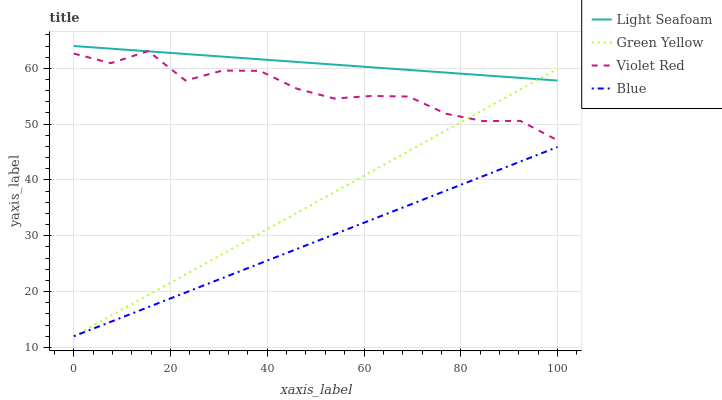Does Blue have the minimum area under the curve?
Answer yes or no. Yes. Does Light Seafoam have the maximum area under the curve?
Answer yes or no. Yes. Does Green Yellow have the minimum area under the curve?
Answer yes or no. No. Does Green Yellow have the maximum area under the curve?
Answer yes or no. No. Is Blue the smoothest?
Answer yes or no. Yes. Is Violet Red the roughest?
Answer yes or no. Yes. Is Green Yellow the smoothest?
Answer yes or no. No. Is Green Yellow the roughest?
Answer yes or no. No. Does Blue have the lowest value?
Answer yes or no. Yes. Does Light Seafoam have the lowest value?
Answer yes or no. No. Does Light Seafoam have the highest value?
Answer yes or no. Yes. Does Green Yellow have the highest value?
Answer yes or no. No. Is Blue less than Light Seafoam?
Answer yes or no. Yes. Is Violet Red greater than Blue?
Answer yes or no. Yes. Does Green Yellow intersect Violet Red?
Answer yes or no. Yes. Is Green Yellow less than Violet Red?
Answer yes or no. No. Is Green Yellow greater than Violet Red?
Answer yes or no. No. Does Blue intersect Light Seafoam?
Answer yes or no. No. 